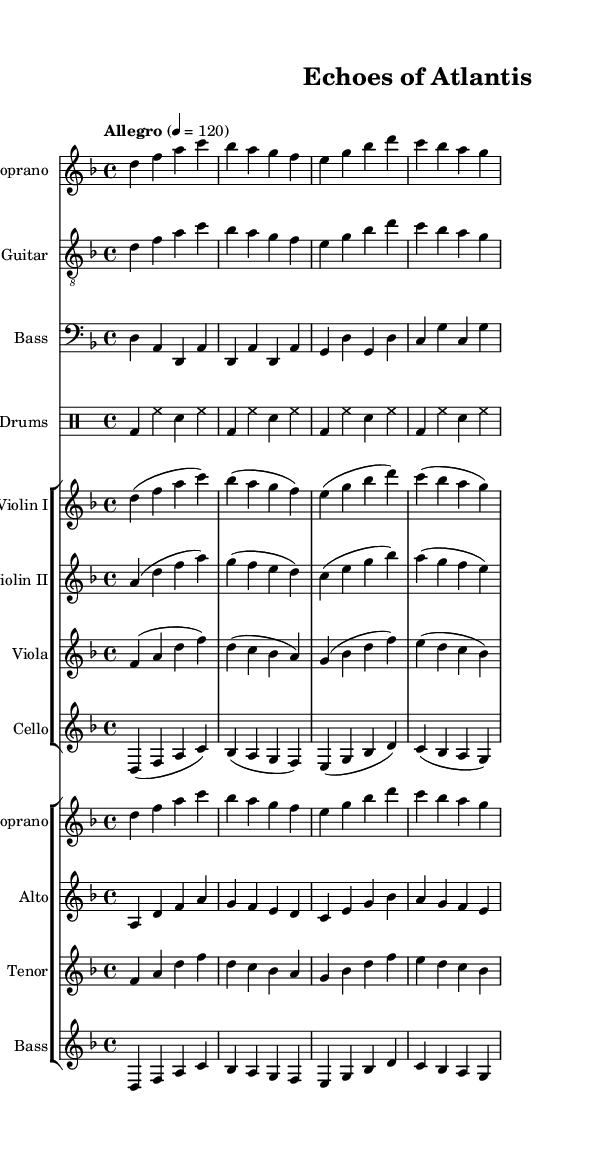What is the key signature of this music? The key signature is D minor, which contains one flat (B flat). This can be determined by looking at the key signature indicated at the beginning of the staff sections.
Answer: D minor What is the time signature of this music? The time signature is 4/4, meaning there are four beats in each measure and the quarter note gets one beat. This information appears at the start of the piece and is rectangular in shape.
Answer: 4/4 What is the tempo marking given in this sheet? The tempo marking is "Allegro" with a metronome speed of 120 beats per minute. This indicates a fast and lively pace for the music, stated directly under the header section.
Answer: Allegro How many instruments are involved in this composition? There are ten distinct musical parts, including vocal and instrumental sections listed in the score. By counting each staff shown in the score, we arrive at this total.
Answer: 10 Which section features the electric guitar? The electric guitar is featured in the "E. Guitar" staff, which is clearly labeled in the score layout. This staff plays a part that complements the harmonies.
Answer: E. Guitar What type of drum pattern is indicated in this music? The drum pattern primarily consists of a bass drum and hi-hat as basic components, indicated in a rhythmic format in the drummode section. This repetitive pattern gives a driving force typical of metal music.
Answer: Bass and hi-hat Which ancient civilization does the title "Echoes of Atlantis" refer to? The title refers to Atlantis, a mythical ancient civilization that has captured the imagination of many and serves as a thematic element in this symphonic metal piece, suggesting a connection to lost history.
Answer: Atlantis 